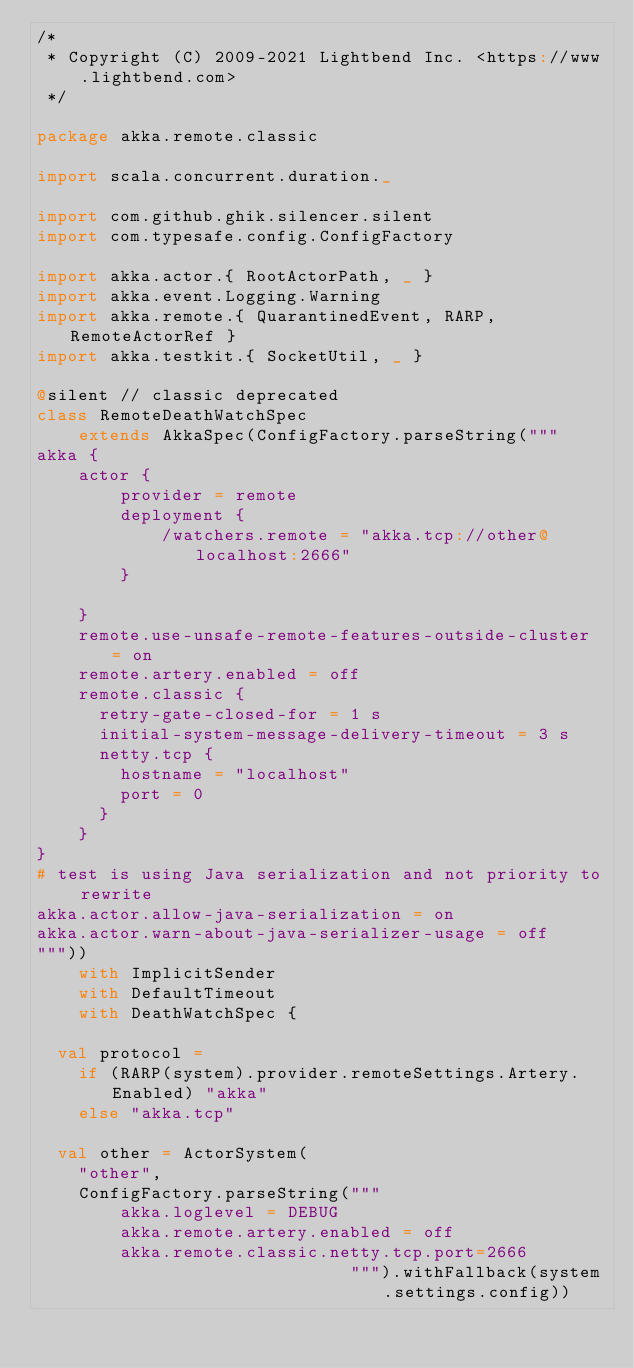Convert code to text. <code><loc_0><loc_0><loc_500><loc_500><_Scala_>/*
 * Copyright (C) 2009-2021 Lightbend Inc. <https://www.lightbend.com>
 */

package akka.remote.classic

import scala.concurrent.duration._

import com.github.ghik.silencer.silent
import com.typesafe.config.ConfigFactory

import akka.actor.{ RootActorPath, _ }
import akka.event.Logging.Warning
import akka.remote.{ QuarantinedEvent, RARP, RemoteActorRef }
import akka.testkit.{ SocketUtil, _ }

@silent // classic deprecated
class RemoteDeathWatchSpec
    extends AkkaSpec(ConfigFactory.parseString("""
akka {
    actor {
        provider = remote
        deployment {
            /watchers.remote = "akka.tcp://other@localhost:2666"
        }

    }
    remote.use-unsafe-remote-features-outside-cluster = on
    remote.artery.enabled = off
    remote.classic {
      retry-gate-closed-for = 1 s
      initial-system-message-delivery-timeout = 3 s
      netty.tcp {
        hostname = "localhost"
        port = 0
      }
    }
}
# test is using Java serialization and not priority to rewrite
akka.actor.allow-java-serialization = on
akka.actor.warn-about-java-serializer-usage = off
"""))
    with ImplicitSender
    with DefaultTimeout
    with DeathWatchSpec {

  val protocol =
    if (RARP(system).provider.remoteSettings.Artery.Enabled) "akka"
    else "akka.tcp"

  val other = ActorSystem(
    "other",
    ConfigFactory.parseString("""
        akka.loglevel = DEBUG
        akka.remote.artery.enabled = off
        akka.remote.classic.netty.tcp.port=2666
                              """).withFallback(system.settings.config))
</code> 